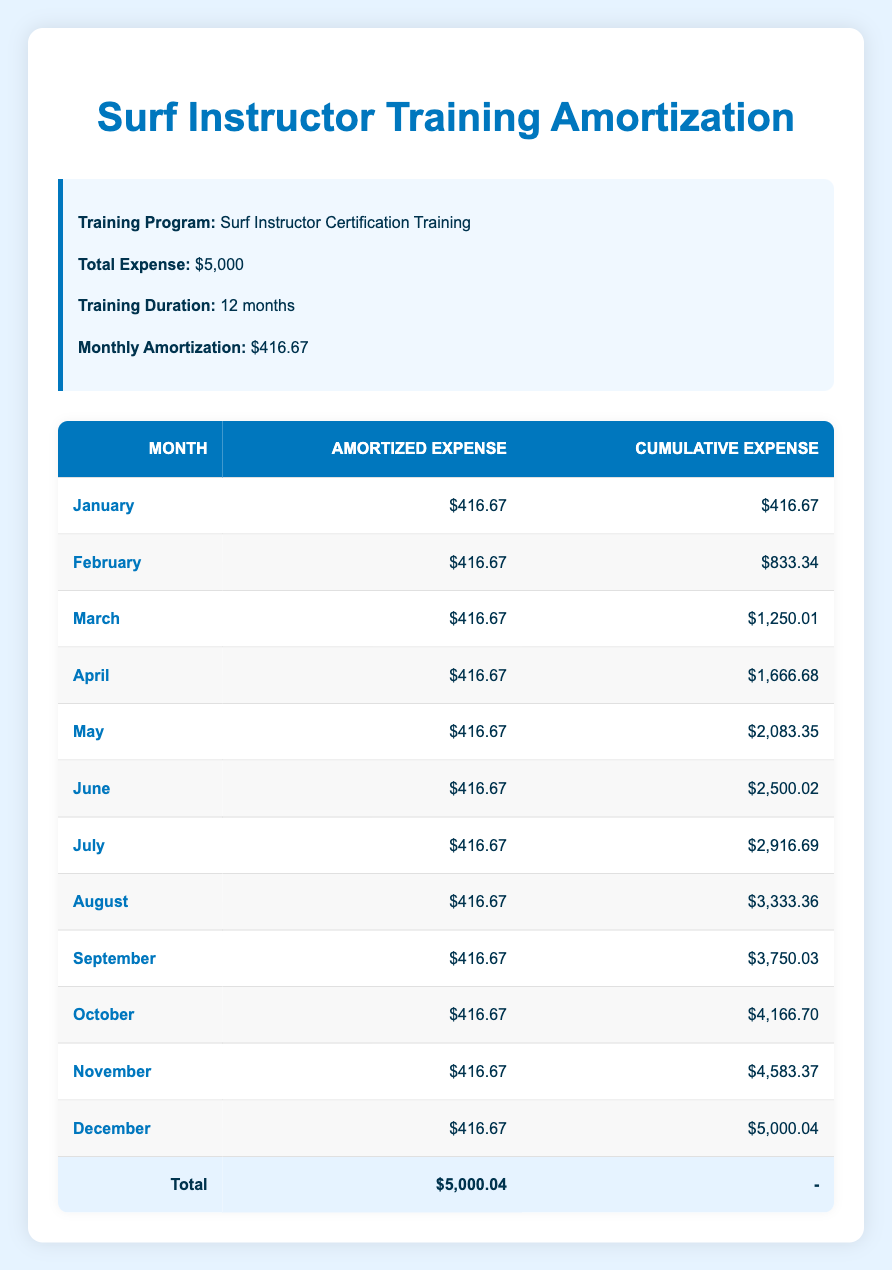What is the total training expense for the Surf Instructor Certification Training? The total expense is directly stated in the table under "Total Expense," which is $5,000.
Answer: $5,000 How much is the monthly amortization for the training expense? The monthly amortization is provided in the table as $416.67.
Answer: $416.67 What was the cumulative expense at the end of June? To find the cumulative expense for June, we refer to the "Cumulative Expense" column, which shows $2,500.02.
Answer: $2,500.02 In which month does the cumulative expense first exceed $3,000? By checking the cumulative expenses from the table, the value exceeds $3,000 for the first time in August ($3,333.36).
Answer: August Is the amortized expense consistent every month? Yes, by checking the "Amortized Expense" column, we notice that each month has the same value of $416.67.
Answer: Yes How much did the cumulative expense increase from February to March? The cumulative expense for February is $833.34, and for March, it's $1,250.01. The increase is calculated as $1,250.01 - $833.34 = $416.67.
Answer: $416.67 What is the total of the amortized expenses from January to April? The amortized expenses in these months are all $416.67. Adding them gives: $416.67 x 4 = $1,666.68.
Answer: $1,666.68 How much was the cumulative expense in December compared to November? The cumulative expense in December is $5,000.04 and in November is $4,583.37. The difference is $5,000.04 - $4,583.37 = $416.67, which is also the monthly amortization.
Answer: $416.67 What is the average monthly amortization over the training duration? The total amortization is $5,000.04, which is divided by 12 months: $5,000.04 / 12 = $416.67, confirming uniform distribution throughout the 12 months.
Answer: $416.67 